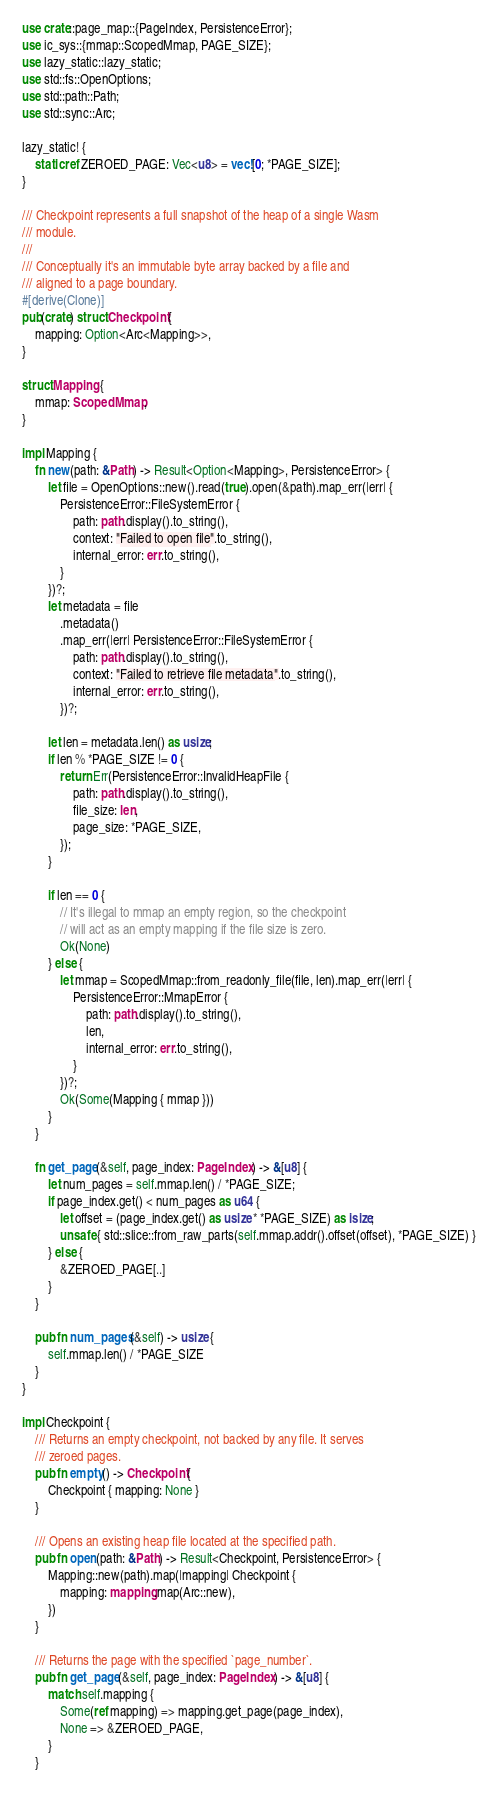Convert code to text. <code><loc_0><loc_0><loc_500><loc_500><_Rust_>use crate::page_map::{PageIndex, PersistenceError};
use ic_sys::{mmap::ScopedMmap, PAGE_SIZE};
use lazy_static::lazy_static;
use std::fs::OpenOptions;
use std::path::Path;
use std::sync::Arc;

lazy_static! {
    static ref ZEROED_PAGE: Vec<u8> = vec![0; *PAGE_SIZE];
}

/// Checkpoint represents a full snapshot of the heap of a single Wasm
/// module.
///
/// Conceptually it's an immutable byte array backed by a file and
/// aligned to a page boundary.
#[derive(Clone)]
pub(crate) struct Checkpoint {
    mapping: Option<Arc<Mapping>>,
}

struct Mapping {
    mmap: ScopedMmap,
}

impl Mapping {
    fn new(path: &Path) -> Result<Option<Mapping>, PersistenceError> {
        let file = OpenOptions::new().read(true).open(&path).map_err(|err| {
            PersistenceError::FileSystemError {
                path: path.display().to_string(),
                context: "Failed to open file".to_string(),
                internal_error: err.to_string(),
            }
        })?;
        let metadata = file
            .metadata()
            .map_err(|err| PersistenceError::FileSystemError {
                path: path.display().to_string(),
                context: "Failed to retrieve file metadata".to_string(),
                internal_error: err.to_string(),
            })?;

        let len = metadata.len() as usize;
        if len % *PAGE_SIZE != 0 {
            return Err(PersistenceError::InvalidHeapFile {
                path: path.display().to_string(),
                file_size: len,
                page_size: *PAGE_SIZE,
            });
        }

        if len == 0 {
            // It's illegal to mmap an empty region, so the checkpoint
            // will act as an empty mapping if the file size is zero.
            Ok(None)
        } else {
            let mmap = ScopedMmap::from_readonly_file(file, len).map_err(|err| {
                PersistenceError::MmapError {
                    path: path.display().to_string(),
                    len,
                    internal_error: err.to_string(),
                }
            })?;
            Ok(Some(Mapping { mmap }))
        }
    }

    fn get_page(&self, page_index: PageIndex) -> &[u8] {
        let num_pages = self.mmap.len() / *PAGE_SIZE;
        if page_index.get() < num_pages as u64 {
            let offset = (page_index.get() as usize * *PAGE_SIZE) as isize;
            unsafe { std::slice::from_raw_parts(self.mmap.addr().offset(offset), *PAGE_SIZE) }
        } else {
            &ZEROED_PAGE[..]
        }
    }

    pub fn num_pages(&self) -> usize {
        self.mmap.len() / *PAGE_SIZE
    }
}

impl Checkpoint {
    /// Returns an empty checkpoint, not backed by any file. It serves
    /// zeroed pages.
    pub fn empty() -> Checkpoint {
        Checkpoint { mapping: None }
    }

    /// Opens an existing heap file located at the specified path.
    pub fn open(path: &Path) -> Result<Checkpoint, PersistenceError> {
        Mapping::new(path).map(|mapping| Checkpoint {
            mapping: mapping.map(Arc::new),
        })
    }

    /// Returns the page with the specified `page_number`.
    pub fn get_page(&self, page_index: PageIndex) -> &[u8] {
        match self.mapping {
            Some(ref mapping) => mapping.get_page(page_index),
            None => &ZEROED_PAGE,
        }
    }
</code> 